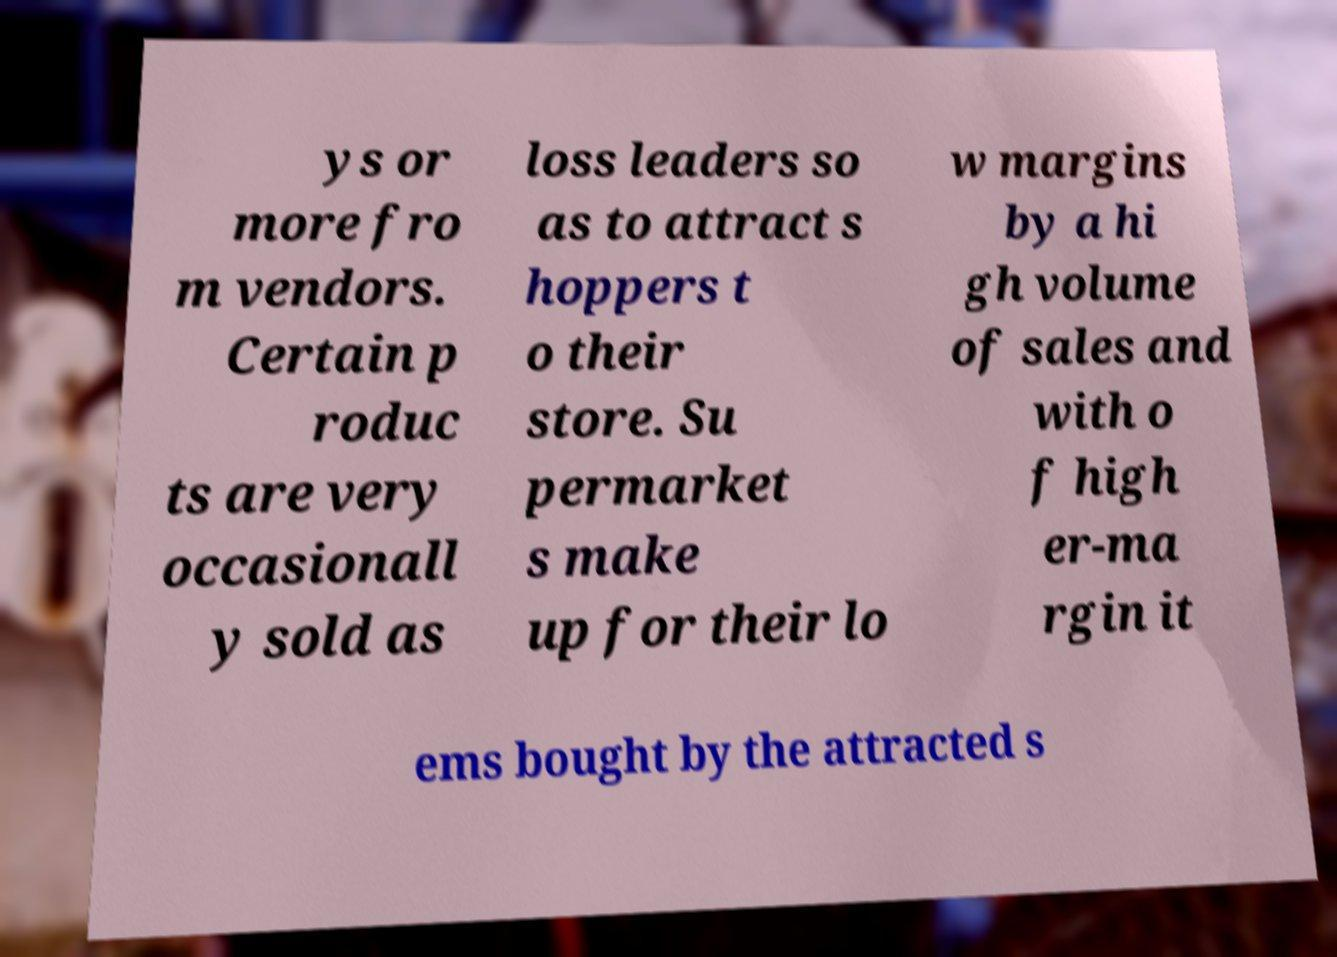What messages or text are displayed in this image? I need them in a readable, typed format. ys or more fro m vendors. Certain p roduc ts are very occasionall y sold as loss leaders so as to attract s hoppers t o their store. Su permarket s make up for their lo w margins by a hi gh volume of sales and with o f high er-ma rgin it ems bought by the attracted s 